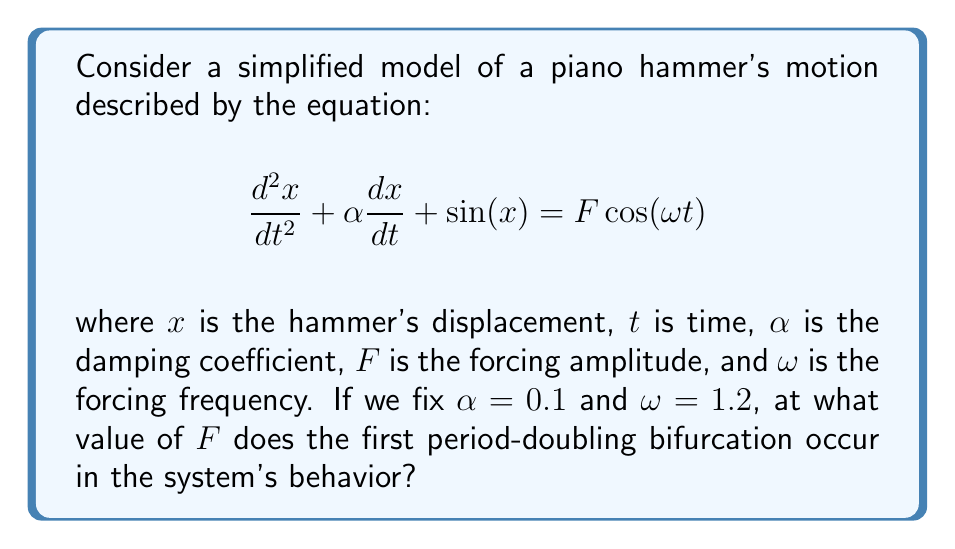Give your solution to this math problem. To find the first period-doubling bifurcation, we need to analyze the system's behavior as we vary the parameter $F$. Here's a step-by-step approach:

1) First, we recognize that this equation represents a forced, damped pendulum system, which is known to exhibit chaotic behavior under certain conditions.

2) To create a bifurcation diagram, we need to solve this differential equation numerically for different values of $F$, while keeping $\alpha = 0.1$ and $\omega = 1.2$ fixed.

3) We use a numerical method (e.g., Runge-Kutta) to solve the equation for a range of $F$ values, typically from 0 to about 1.5.

4) For each $F$ value, we plot the Poincaré section, which involves sampling the solution at regular intervals corresponding to the forcing period $T = \frac{2\pi}{\omega}$.

5) As we increase $F$, we observe the following sequence of behaviors:
   - For small $F$, there's a single fixed point (period-1 orbit)
   - As $F$ increases, this fixed point becomes unstable and splits into two points (period-2 orbit)
   - This splitting is the first period-doubling bifurcation

6) By carefully examining the bifurcation diagram, we can determine that the first period-doubling occurs at approximately $F \approx 1.08$.

7) This value is significant for a pianist, as it represents the forcing amplitude at which the hammer's motion transitions from a simple periodic motion to a more complex one, potentially affecting the instrument's tonal quality.
Answer: $F \approx 1.08$ 